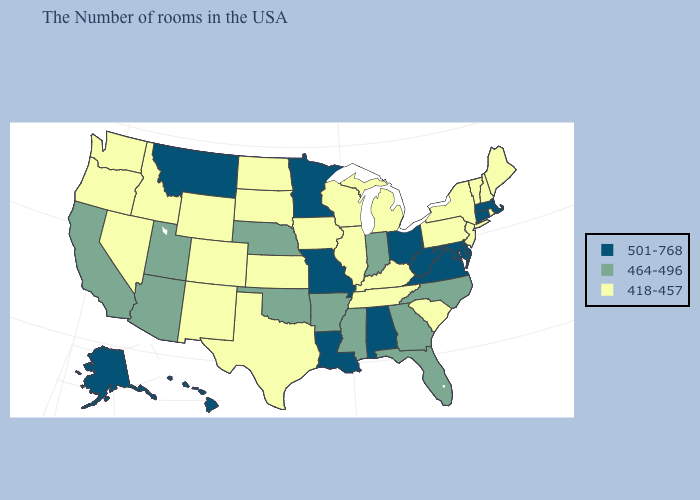What is the lowest value in the USA?
Give a very brief answer. 418-457. What is the value of Washington?
Be succinct. 418-457. Does Minnesota have the lowest value in the MidWest?
Short answer required. No. Name the states that have a value in the range 501-768?
Quick response, please. Massachusetts, Connecticut, Delaware, Maryland, Virginia, West Virginia, Ohio, Alabama, Louisiana, Missouri, Minnesota, Montana, Alaska, Hawaii. What is the highest value in states that border New Mexico?
Give a very brief answer. 464-496. Name the states that have a value in the range 418-457?
Short answer required. Maine, Rhode Island, New Hampshire, Vermont, New York, New Jersey, Pennsylvania, South Carolina, Michigan, Kentucky, Tennessee, Wisconsin, Illinois, Iowa, Kansas, Texas, South Dakota, North Dakota, Wyoming, Colorado, New Mexico, Idaho, Nevada, Washington, Oregon. Name the states that have a value in the range 464-496?
Short answer required. North Carolina, Florida, Georgia, Indiana, Mississippi, Arkansas, Nebraska, Oklahoma, Utah, Arizona, California. Does New Hampshire have the lowest value in the USA?
Keep it brief. Yes. Does the map have missing data?
Keep it brief. No. Name the states that have a value in the range 501-768?
Write a very short answer. Massachusetts, Connecticut, Delaware, Maryland, Virginia, West Virginia, Ohio, Alabama, Louisiana, Missouri, Minnesota, Montana, Alaska, Hawaii. What is the lowest value in states that border Louisiana?
Be succinct. 418-457. Name the states that have a value in the range 418-457?
Give a very brief answer. Maine, Rhode Island, New Hampshire, Vermont, New York, New Jersey, Pennsylvania, South Carolina, Michigan, Kentucky, Tennessee, Wisconsin, Illinois, Iowa, Kansas, Texas, South Dakota, North Dakota, Wyoming, Colorado, New Mexico, Idaho, Nevada, Washington, Oregon. Which states have the highest value in the USA?
Write a very short answer. Massachusetts, Connecticut, Delaware, Maryland, Virginia, West Virginia, Ohio, Alabama, Louisiana, Missouri, Minnesota, Montana, Alaska, Hawaii. Name the states that have a value in the range 501-768?
Write a very short answer. Massachusetts, Connecticut, Delaware, Maryland, Virginia, West Virginia, Ohio, Alabama, Louisiana, Missouri, Minnesota, Montana, Alaska, Hawaii. 